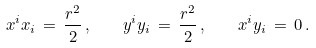<formula> <loc_0><loc_0><loc_500><loc_500>x ^ { i } x _ { i } \, = \, \frac { r ^ { 2 } } { 2 } \, , \quad y ^ { i } y _ { i } \, = \, \frac { r ^ { 2 } } { 2 } \, , \quad x ^ { i } y _ { i } \, = \, 0 \, .</formula> 